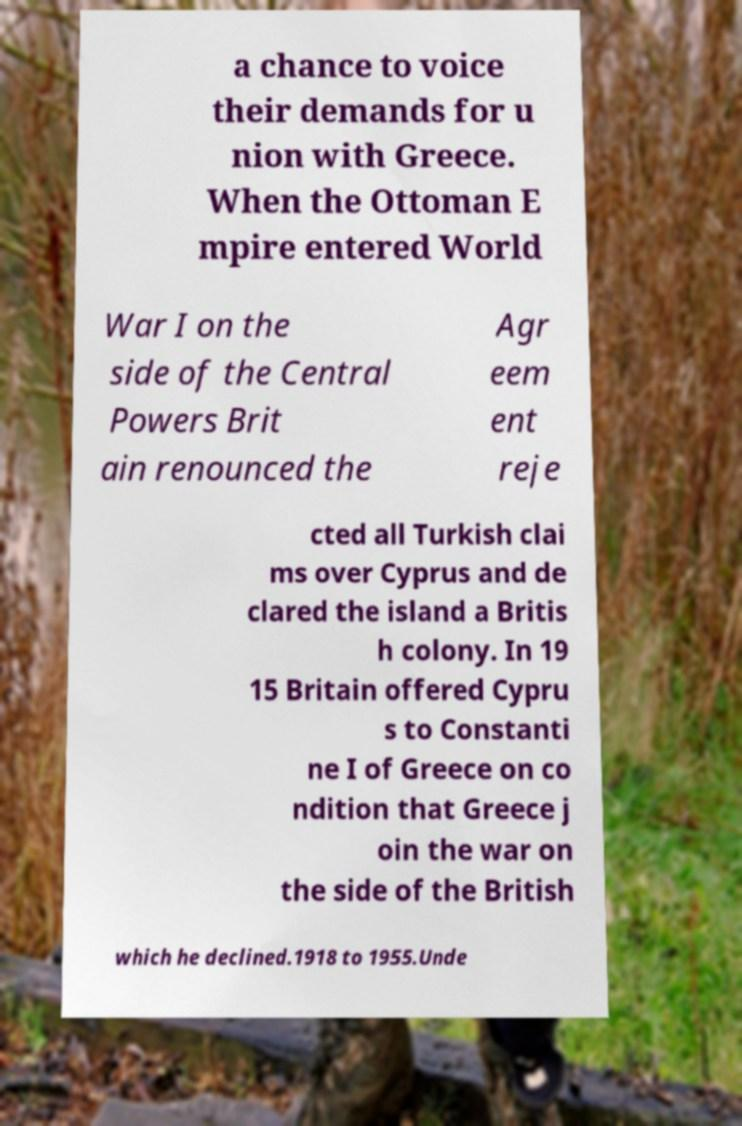Please read and relay the text visible in this image. What does it say? a chance to voice their demands for u nion with Greece. When the Ottoman E mpire entered World War I on the side of the Central Powers Brit ain renounced the Agr eem ent reje cted all Turkish clai ms over Cyprus and de clared the island a Britis h colony. In 19 15 Britain offered Cypru s to Constanti ne I of Greece on co ndition that Greece j oin the war on the side of the British which he declined.1918 to 1955.Unde 